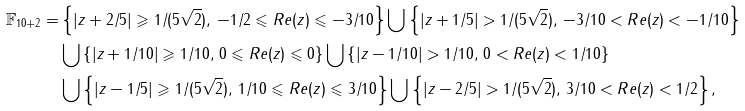Convert formula to latex. <formula><loc_0><loc_0><loc_500><loc_500>\mathbb { F } _ { 1 0 + 2 } = & \left \{ | z + 2 / 5 | \geqslant 1 / ( 5 \sqrt { 2 } ) , \, - 1 / 2 \leqslant R e ( z ) \leqslant - 3 / 1 0 \right \} \bigcup \left \{ | z + 1 / 5 | > 1 / ( 5 \sqrt { 2 } ) , \, - 3 / 1 0 < R e ( z ) < - 1 / 1 0 \right \} \\ & \bigcup \left \{ | z + 1 / 1 0 | \geqslant 1 / 1 0 , \, 0 \leqslant R e ( z ) \leqslant 0 \right \} \bigcup \left \{ | z - 1 / 1 0 | > 1 / 1 0 , \, 0 < R e ( z ) < 1 / 1 0 \right \} \\ & \bigcup \left \{ | z - 1 / 5 | \geqslant 1 / ( 5 \sqrt { 2 } ) , \, 1 / 1 0 \leqslant R e ( z ) \leqslant 3 / 1 0 \right \} \bigcup \left \{ | z - 2 / 5 | > 1 / ( 5 \sqrt { 2 } ) , \, 3 / 1 0 < R e ( z ) < 1 / 2 \right \} ,</formula> 